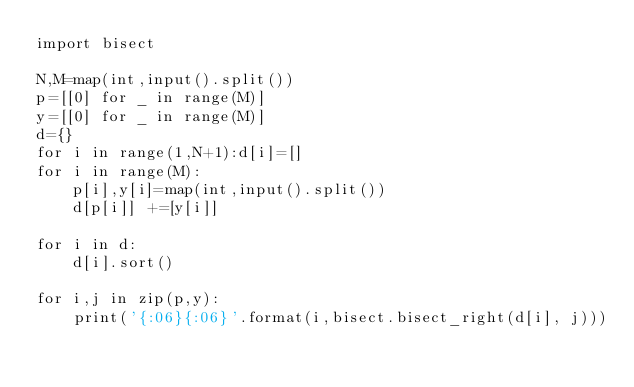Convert code to text. <code><loc_0><loc_0><loc_500><loc_500><_Python_>import bisect

N,M=map(int,input().split())
p=[[0] for _ in range(M)]
y=[[0] for _ in range(M)]
d={}
for i in range(1,N+1):d[i]=[]
for i in range(M):
    p[i],y[i]=map(int,input().split())
    d[p[i]] +=[y[i]]

for i in d:
    d[i].sort()

for i,j in zip(p,y):
    print('{:06}{:06}'.format(i,bisect.bisect_right(d[i], j)))
    </code> 